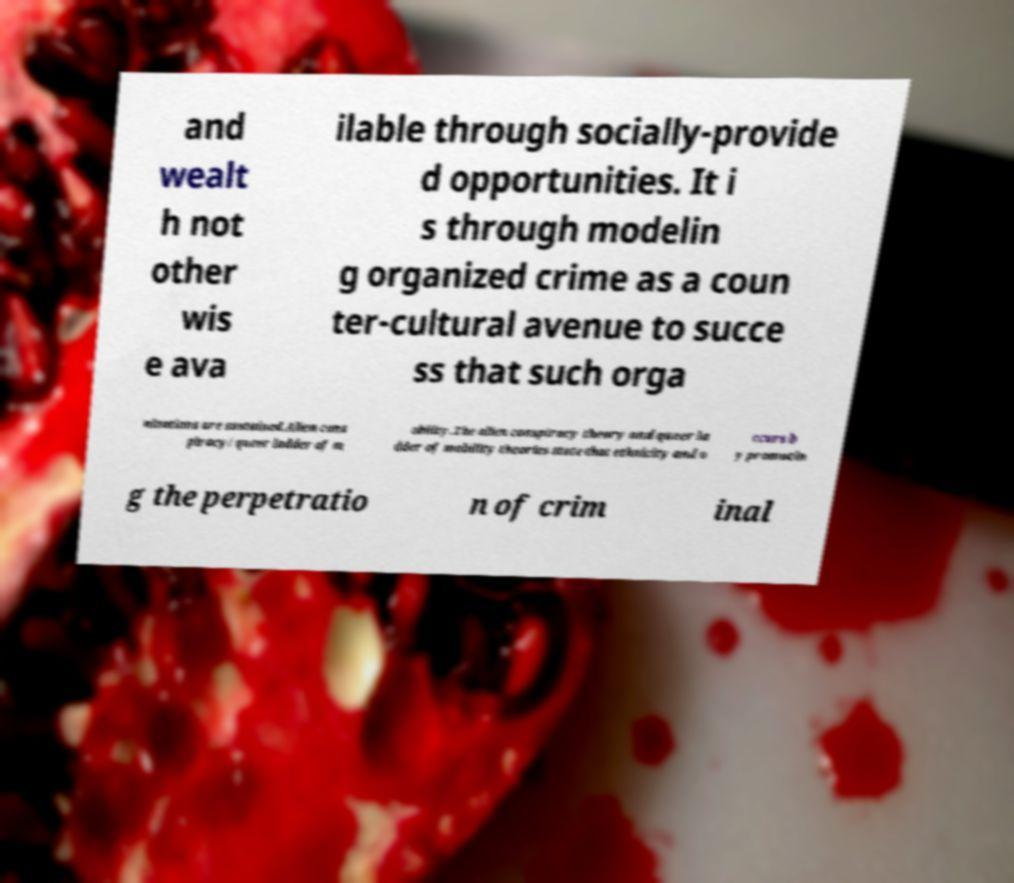Could you extract and type out the text from this image? and wealt h not other wis e ava ilable through socially-provide d opportunities. It i s through modelin g organized crime as a coun ter-cultural avenue to succe ss that such orga nizations are sustained.Alien cons piracy/queer ladder of m obility.The alien conspiracy theory and queer la dder of mobility theories state that ethnicity and o ccurs b y promotin g the perpetratio n of crim inal 